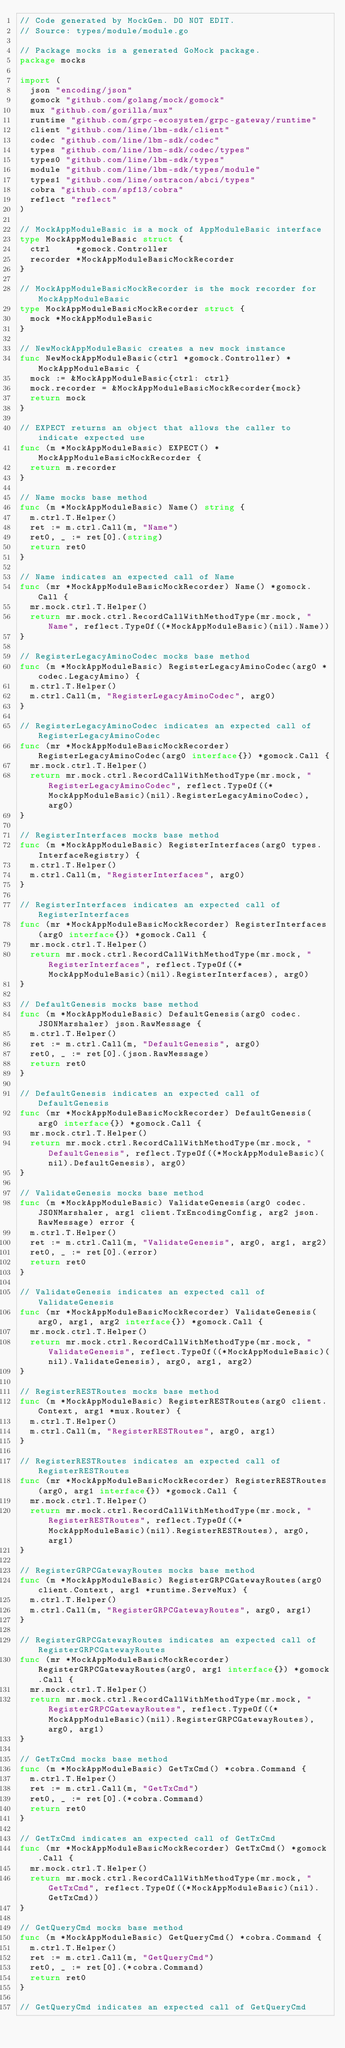Convert code to text. <code><loc_0><loc_0><loc_500><loc_500><_Go_>// Code generated by MockGen. DO NOT EDIT.
// Source: types/module/module.go

// Package mocks is a generated GoMock package.
package mocks

import (
	json "encoding/json"
	gomock "github.com/golang/mock/gomock"
	mux "github.com/gorilla/mux"
	runtime "github.com/grpc-ecosystem/grpc-gateway/runtime"
	client "github.com/line/lbm-sdk/client"
	codec "github.com/line/lbm-sdk/codec"
	types "github.com/line/lbm-sdk/codec/types"
	types0 "github.com/line/lbm-sdk/types"
	module "github.com/line/lbm-sdk/types/module"
	types1 "github.com/line/ostracon/abci/types"
	cobra "github.com/spf13/cobra"
	reflect "reflect"
)

// MockAppModuleBasic is a mock of AppModuleBasic interface
type MockAppModuleBasic struct {
	ctrl     *gomock.Controller
	recorder *MockAppModuleBasicMockRecorder
}

// MockAppModuleBasicMockRecorder is the mock recorder for MockAppModuleBasic
type MockAppModuleBasicMockRecorder struct {
	mock *MockAppModuleBasic
}

// NewMockAppModuleBasic creates a new mock instance
func NewMockAppModuleBasic(ctrl *gomock.Controller) *MockAppModuleBasic {
	mock := &MockAppModuleBasic{ctrl: ctrl}
	mock.recorder = &MockAppModuleBasicMockRecorder{mock}
	return mock
}

// EXPECT returns an object that allows the caller to indicate expected use
func (m *MockAppModuleBasic) EXPECT() *MockAppModuleBasicMockRecorder {
	return m.recorder
}

// Name mocks base method
func (m *MockAppModuleBasic) Name() string {
	m.ctrl.T.Helper()
	ret := m.ctrl.Call(m, "Name")
	ret0, _ := ret[0].(string)
	return ret0
}

// Name indicates an expected call of Name
func (mr *MockAppModuleBasicMockRecorder) Name() *gomock.Call {
	mr.mock.ctrl.T.Helper()
	return mr.mock.ctrl.RecordCallWithMethodType(mr.mock, "Name", reflect.TypeOf((*MockAppModuleBasic)(nil).Name))
}

// RegisterLegacyAminoCodec mocks base method
func (m *MockAppModuleBasic) RegisterLegacyAminoCodec(arg0 *codec.LegacyAmino) {
	m.ctrl.T.Helper()
	m.ctrl.Call(m, "RegisterLegacyAminoCodec", arg0)
}

// RegisterLegacyAminoCodec indicates an expected call of RegisterLegacyAminoCodec
func (mr *MockAppModuleBasicMockRecorder) RegisterLegacyAminoCodec(arg0 interface{}) *gomock.Call {
	mr.mock.ctrl.T.Helper()
	return mr.mock.ctrl.RecordCallWithMethodType(mr.mock, "RegisterLegacyAminoCodec", reflect.TypeOf((*MockAppModuleBasic)(nil).RegisterLegacyAminoCodec), arg0)
}

// RegisterInterfaces mocks base method
func (m *MockAppModuleBasic) RegisterInterfaces(arg0 types.InterfaceRegistry) {
	m.ctrl.T.Helper()
	m.ctrl.Call(m, "RegisterInterfaces", arg0)
}

// RegisterInterfaces indicates an expected call of RegisterInterfaces
func (mr *MockAppModuleBasicMockRecorder) RegisterInterfaces(arg0 interface{}) *gomock.Call {
	mr.mock.ctrl.T.Helper()
	return mr.mock.ctrl.RecordCallWithMethodType(mr.mock, "RegisterInterfaces", reflect.TypeOf((*MockAppModuleBasic)(nil).RegisterInterfaces), arg0)
}

// DefaultGenesis mocks base method
func (m *MockAppModuleBasic) DefaultGenesis(arg0 codec.JSONMarshaler) json.RawMessage {
	m.ctrl.T.Helper()
	ret := m.ctrl.Call(m, "DefaultGenesis", arg0)
	ret0, _ := ret[0].(json.RawMessage)
	return ret0
}

// DefaultGenesis indicates an expected call of DefaultGenesis
func (mr *MockAppModuleBasicMockRecorder) DefaultGenesis(arg0 interface{}) *gomock.Call {
	mr.mock.ctrl.T.Helper()
	return mr.mock.ctrl.RecordCallWithMethodType(mr.mock, "DefaultGenesis", reflect.TypeOf((*MockAppModuleBasic)(nil).DefaultGenesis), arg0)
}

// ValidateGenesis mocks base method
func (m *MockAppModuleBasic) ValidateGenesis(arg0 codec.JSONMarshaler, arg1 client.TxEncodingConfig, arg2 json.RawMessage) error {
	m.ctrl.T.Helper()
	ret := m.ctrl.Call(m, "ValidateGenesis", arg0, arg1, arg2)
	ret0, _ := ret[0].(error)
	return ret0
}

// ValidateGenesis indicates an expected call of ValidateGenesis
func (mr *MockAppModuleBasicMockRecorder) ValidateGenesis(arg0, arg1, arg2 interface{}) *gomock.Call {
	mr.mock.ctrl.T.Helper()
	return mr.mock.ctrl.RecordCallWithMethodType(mr.mock, "ValidateGenesis", reflect.TypeOf((*MockAppModuleBasic)(nil).ValidateGenesis), arg0, arg1, arg2)
}

// RegisterRESTRoutes mocks base method
func (m *MockAppModuleBasic) RegisterRESTRoutes(arg0 client.Context, arg1 *mux.Router) {
	m.ctrl.T.Helper()
	m.ctrl.Call(m, "RegisterRESTRoutes", arg0, arg1)
}

// RegisterRESTRoutes indicates an expected call of RegisterRESTRoutes
func (mr *MockAppModuleBasicMockRecorder) RegisterRESTRoutes(arg0, arg1 interface{}) *gomock.Call {
	mr.mock.ctrl.T.Helper()
	return mr.mock.ctrl.RecordCallWithMethodType(mr.mock, "RegisterRESTRoutes", reflect.TypeOf((*MockAppModuleBasic)(nil).RegisterRESTRoutes), arg0, arg1)
}

// RegisterGRPCGatewayRoutes mocks base method
func (m *MockAppModuleBasic) RegisterGRPCGatewayRoutes(arg0 client.Context, arg1 *runtime.ServeMux) {
	m.ctrl.T.Helper()
	m.ctrl.Call(m, "RegisterGRPCGatewayRoutes", arg0, arg1)
}

// RegisterGRPCGatewayRoutes indicates an expected call of RegisterGRPCGatewayRoutes
func (mr *MockAppModuleBasicMockRecorder) RegisterGRPCGatewayRoutes(arg0, arg1 interface{}) *gomock.Call {
	mr.mock.ctrl.T.Helper()
	return mr.mock.ctrl.RecordCallWithMethodType(mr.mock, "RegisterGRPCGatewayRoutes", reflect.TypeOf((*MockAppModuleBasic)(nil).RegisterGRPCGatewayRoutes), arg0, arg1)
}

// GetTxCmd mocks base method
func (m *MockAppModuleBasic) GetTxCmd() *cobra.Command {
	m.ctrl.T.Helper()
	ret := m.ctrl.Call(m, "GetTxCmd")
	ret0, _ := ret[0].(*cobra.Command)
	return ret0
}

// GetTxCmd indicates an expected call of GetTxCmd
func (mr *MockAppModuleBasicMockRecorder) GetTxCmd() *gomock.Call {
	mr.mock.ctrl.T.Helper()
	return mr.mock.ctrl.RecordCallWithMethodType(mr.mock, "GetTxCmd", reflect.TypeOf((*MockAppModuleBasic)(nil).GetTxCmd))
}

// GetQueryCmd mocks base method
func (m *MockAppModuleBasic) GetQueryCmd() *cobra.Command {
	m.ctrl.T.Helper()
	ret := m.ctrl.Call(m, "GetQueryCmd")
	ret0, _ := ret[0].(*cobra.Command)
	return ret0
}

// GetQueryCmd indicates an expected call of GetQueryCmd</code> 